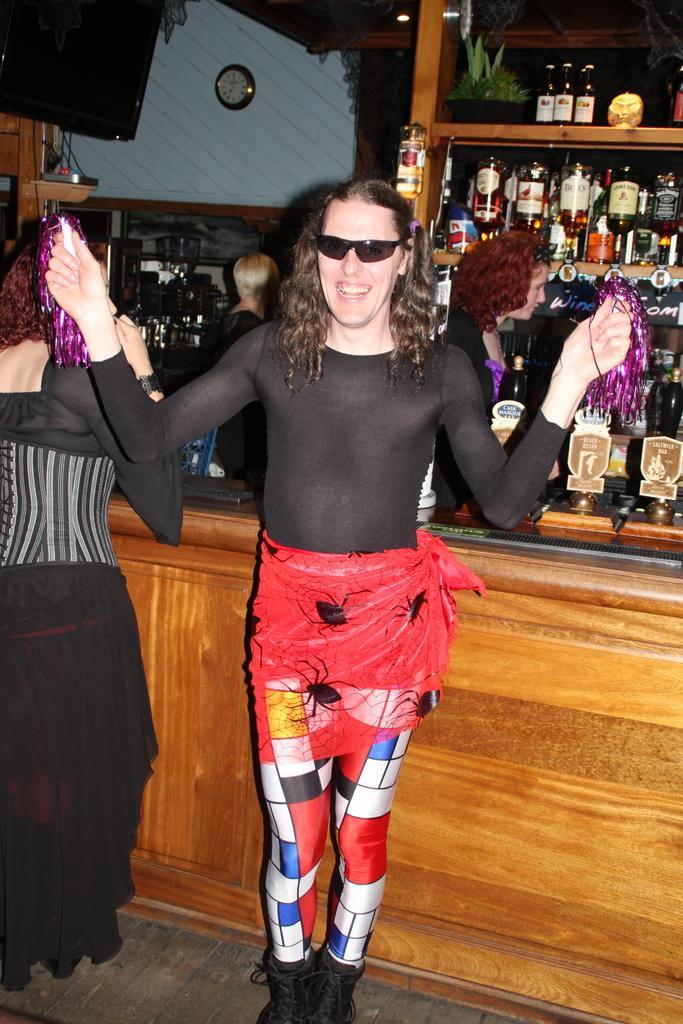Could you give a brief overview of what you see in this image? In the center of the image there is a woman standing on the floor. On the left side of the image we can see speaker and woman standing at the table. In the background we can see beverage bottles arranged in racks and clock. 